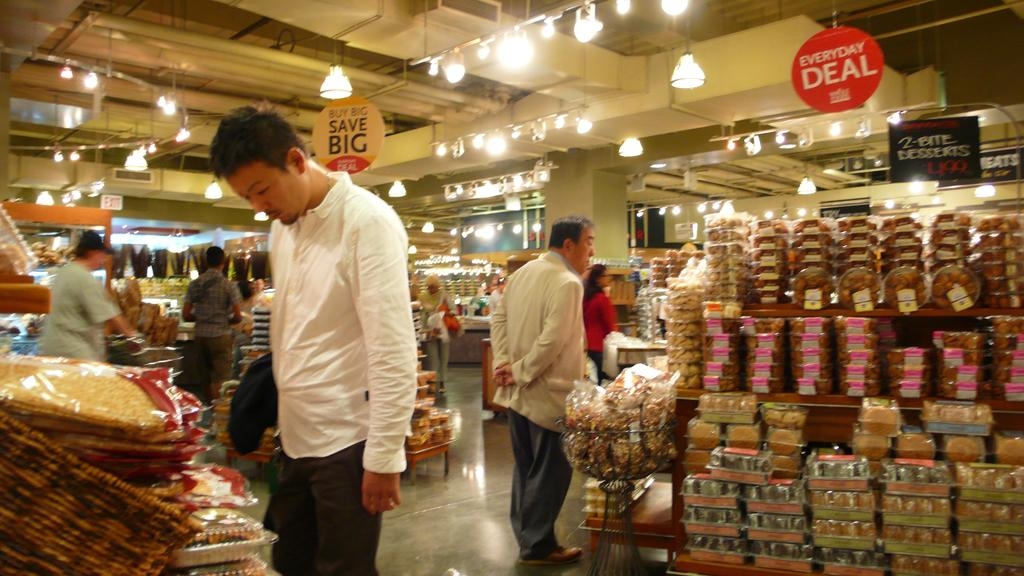<image>
Provide a brief description of the given image. a sign that says deal is above the store 